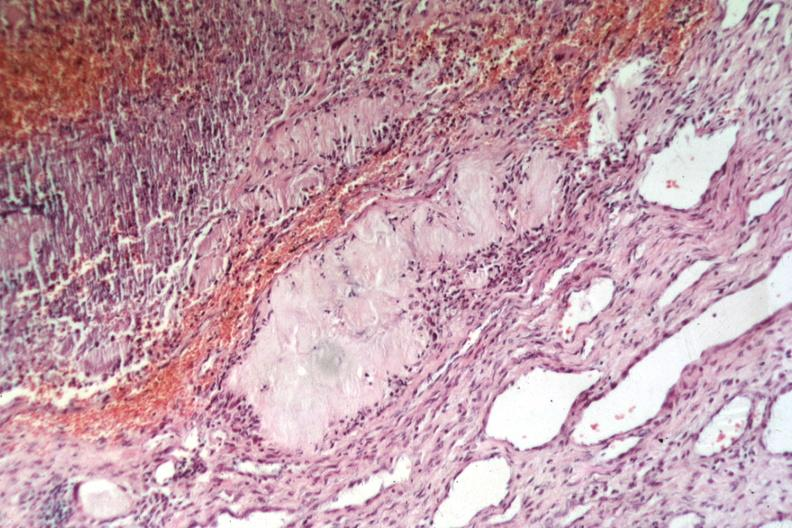what is present?
Answer the question using a single word or phrase. Tophus 